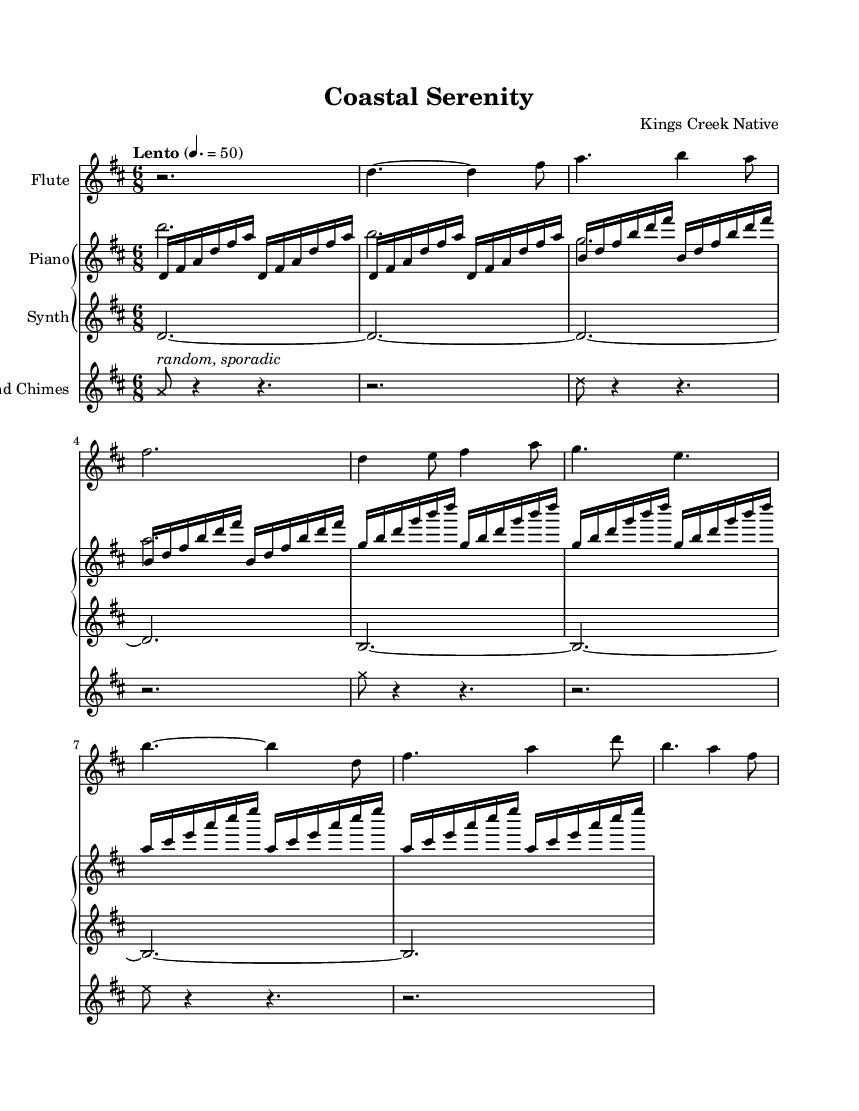What is the key signature of this music? The key signature is located at the beginning of the staff and indicates two sharps, which corresponds to D major.
Answer: D major What is the time signature of this music? The time signature is found right after the key signature and indicates a compound meter of six eighth notes per measure.
Answer: Six eighths What is the tempo marking given in this piece? The tempo marking, found just below the title, indicates a slow pace with a marked speed of 50 beats per minute in a Lento style.
Answer: Lento How many measures are in the flute part? Counting each vertical line (bar line) in the flute part, there are a total of 8 measures.
Answer: Eight Which instrument has random and sporadic notes? This characteristic is assigned to the Wind Chimes, indicated by the description next to the notes in the score.
Answer: Wind Chimes What rhythmic grouping is primarily used in the piano part? The piano part primarily uses repeating sixteenth notes grouped in sets of four, creating a flowing, repetitive texture throughout.
Answer: Sixteenth notes Which instrument plays sustained notes throughout the music? The synthesizer part features long sustained notes, evident by the use of tied notes that create a continuous sound over several measures.
Answer: Synthesizer 